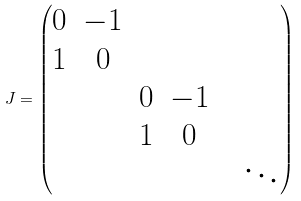<formula> <loc_0><loc_0><loc_500><loc_500>J = \begin{pmatrix} 0 & - 1 & & & \\ 1 & 0 & & & \\ & & 0 & - 1 & \\ & & 1 & 0 & \\ & & & & & \ddots \end{pmatrix}</formula> 